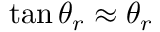<formula> <loc_0><loc_0><loc_500><loc_500>\tan \theta _ { r } \approx \theta _ { r }</formula> 